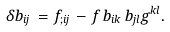<formula> <loc_0><loc_0><loc_500><loc_500>\delta b _ { i j } \, = \, f _ { ; i j } \, - \, f \, b _ { i k } \, b _ { j l } g ^ { k l } .</formula> 